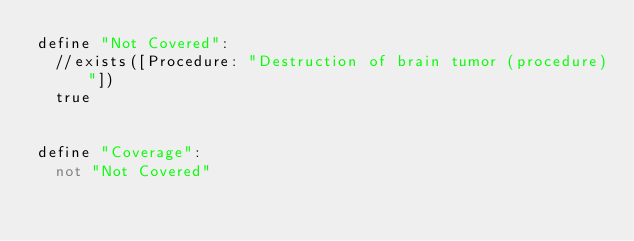Convert code to text. <code><loc_0><loc_0><loc_500><loc_500><_SQL_>define "Not Covered":
	//exists([Procedure: "Destruction of brain tumor (procedure)"])
	true
	
	
define "Coverage":
	not "Not Covered"
</code> 